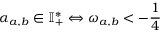Convert formula to latex. <formula><loc_0><loc_0><loc_500><loc_500>\alpha _ { a , b } \in \mathbb { I } _ { + } ^ { * } \Leftrightarrow \omega _ { a , b } < - \frac { 1 } { 4 }</formula> 